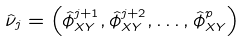Convert formula to latex. <formula><loc_0><loc_0><loc_500><loc_500>\hat { \nu } _ { j } = \left ( \hat { \phi } _ { X Y } ^ { j + 1 } , \hat { \phi } _ { X Y } ^ { j + 2 } , \dots , \hat { \phi } _ { X Y } ^ { p } \right )</formula> 